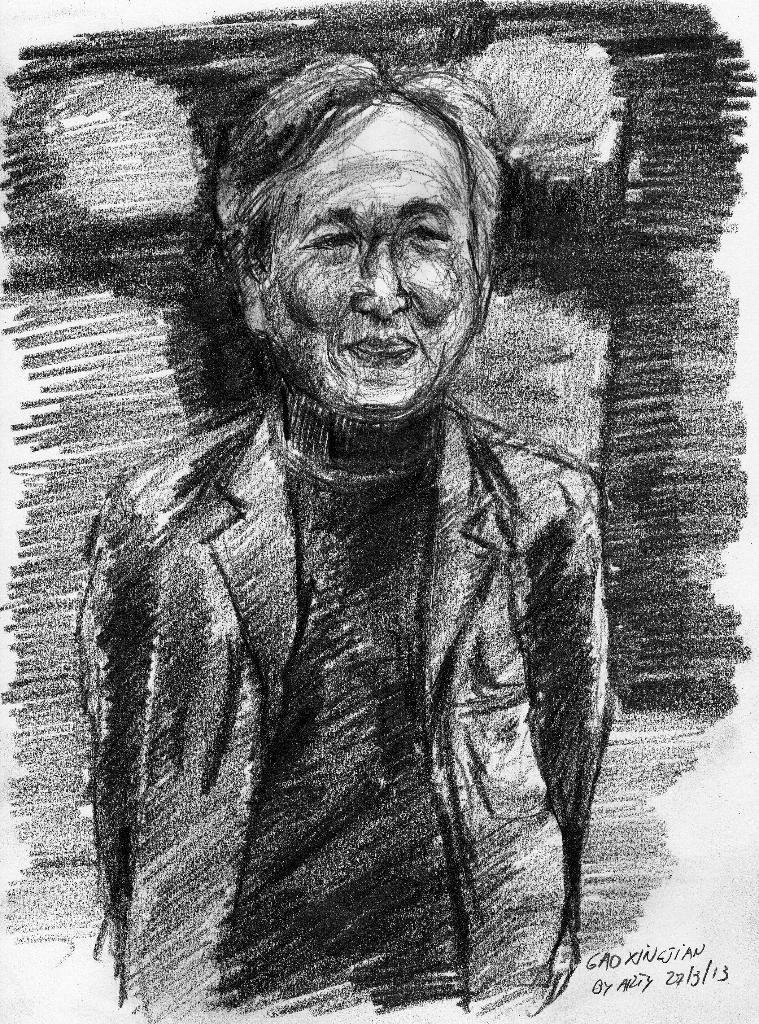What is the main subject of the image? The main subject of the image is a sketch of a person. Is there any text associated with the image? Yes, there is text at the bottom of the image. What type of throne is depicted in the image? There is no throne present in the image; it features a sketch of a person and text at the bottom. 